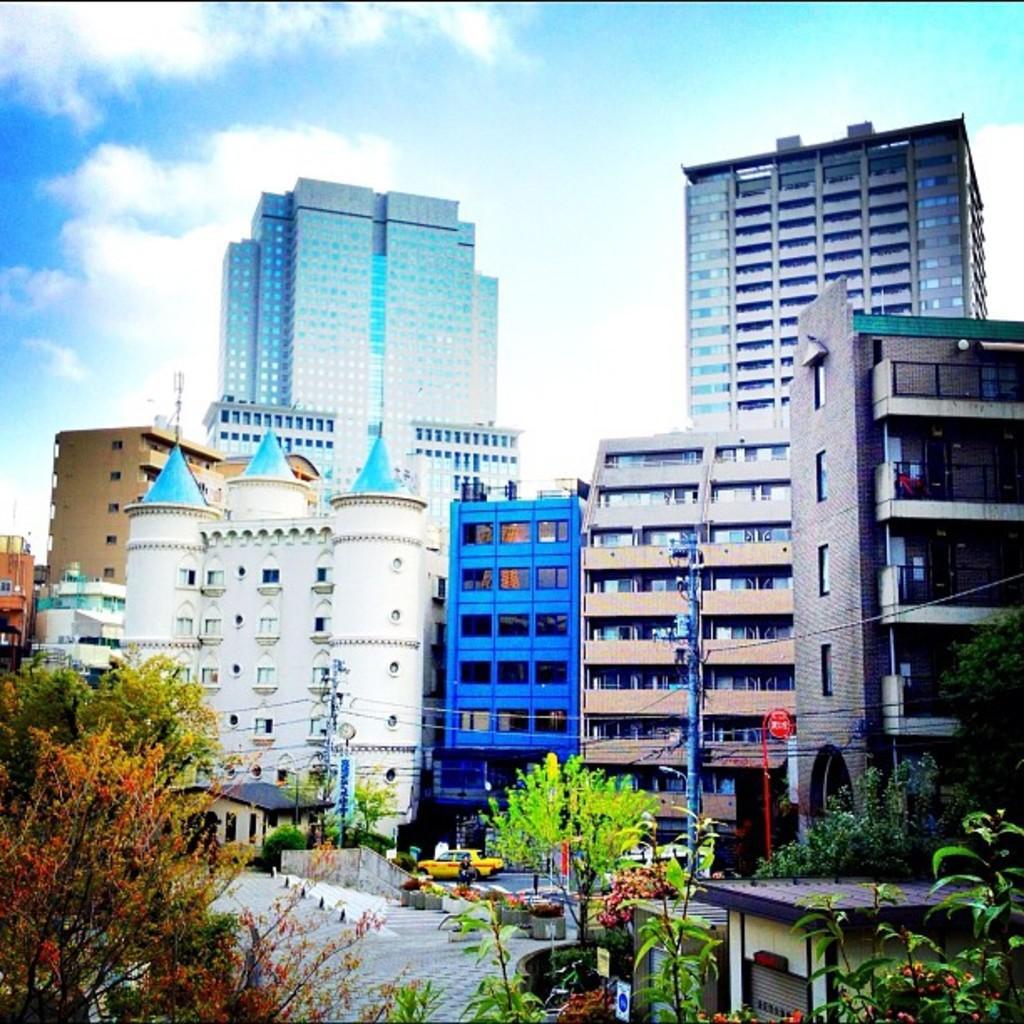In one or two sentences, can you explain what this image depicts? In this image in the front there are plants and in the center there is a car which is yellow in colour and there are trees. In the background there are buildings and the sky is cloudy. 